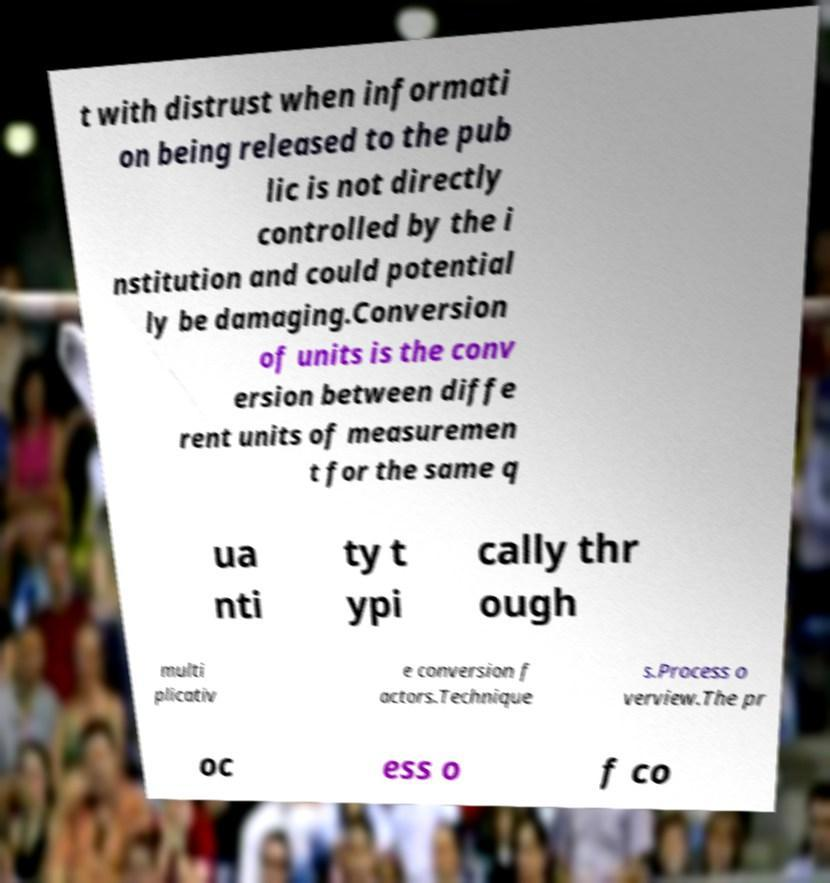Could you extract and type out the text from this image? t with distrust when informati on being released to the pub lic is not directly controlled by the i nstitution and could potential ly be damaging.Conversion of units is the conv ersion between diffe rent units of measuremen t for the same q ua nti ty t ypi cally thr ough multi plicativ e conversion f actors.Technique s.Process o verview.The pr oc ess o f co 